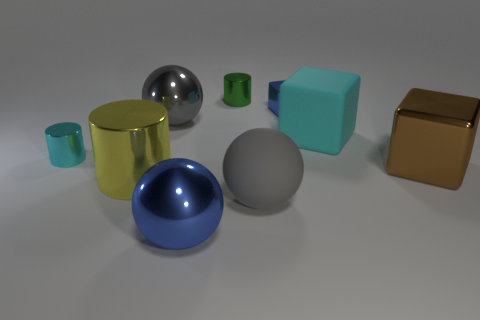The shiny thing that is the same color as the rubber cube is what size?
Your answer should be compact. Small. There is a blue object that is the same shape as the big gray matte thing; what is its material?
Offer a terse response. Metal. There is a cyan cube that is the same size as the blue sphere; what is its material?
Ensure brevity in your answer.  Rubber. The tiny metallic cylinder that is right of the small shiny object that is in front of the blue metallic object that is right of the large blue metal object is what color?
Your answer should be compact. Green. There is a metallic sphere that is behind the large shiny cube; is it the same color as the big block that is behind the brown object?
Offer a very short reply. No. Is there anything else that is the same color as the large rubber block?
Offer a very short reply. Yes. Are there fewer large cylinders that are behind the large rubber block than small brown cylinders?
Your answer should be compact. No. How many big purple matte cylinders are there?
Offer a very short reply. 0. There is a small blue object; is its shape the same as the blue metal object that is in front of the gray rubber ball?
Your response must be concise. No. Are there fewer blue things behind the brown cube than things on the right side of the big yellow shiny object?
Provide a succinct answer. Yes. 